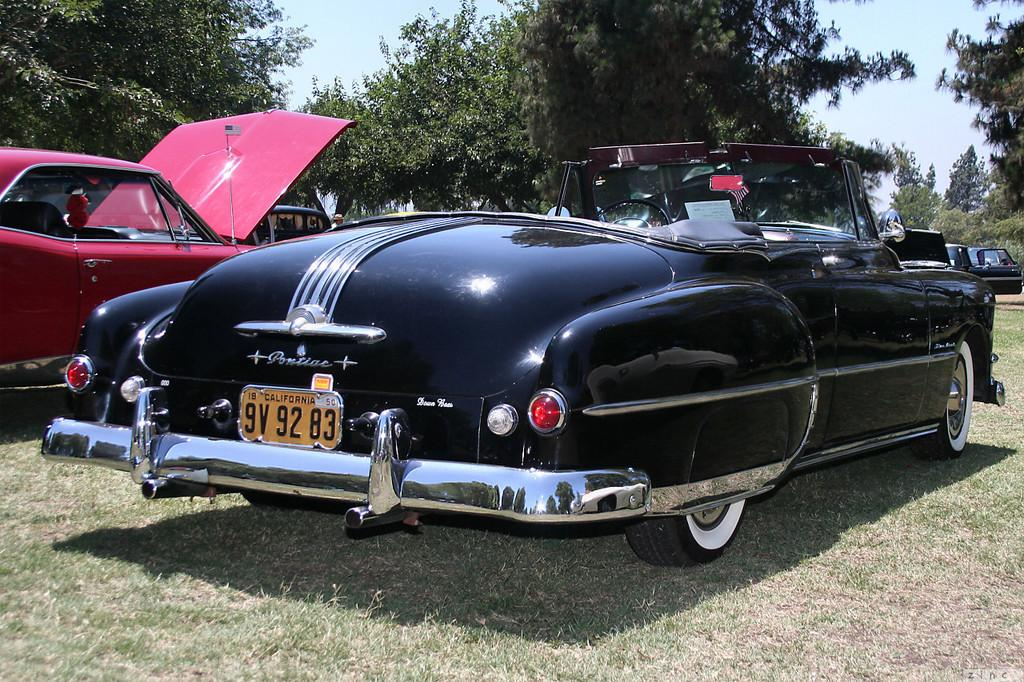What type of vehicles are on the grassland in the image? There are cars on the grassland in the image. What can be seen in the background of the image? There are trees in the background of the image. What is visible at the top of the image? The sky is visible at the top of the image. Where is the mom in the image? There is no mom present in the image. What type of bears can be seen interacting with the cars on the grassland? There are no bears present in the image; it features cars on a grassland with trees in the background and the sky visible at the top. 